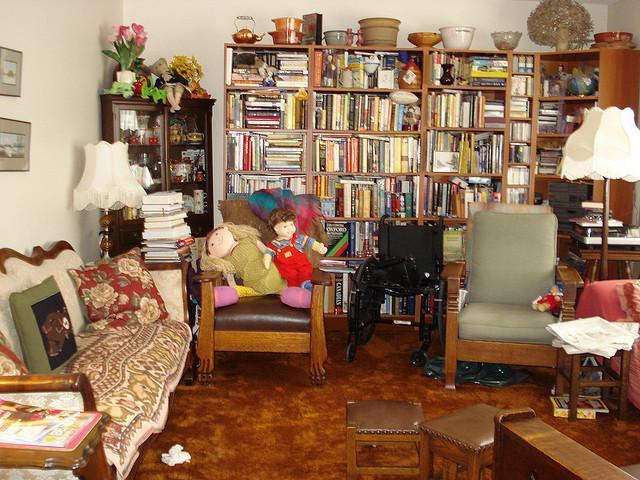How many lamps shades are there?
Give a very brief answer. 2. How many books are in the picture?
Give a very brief answer. 3. How many couches are there?
Give a very brief answer. 2. How many chairs can you see?
Give a very brief answer. 2. How many birds are there?
Give a very brief answer. 0. 